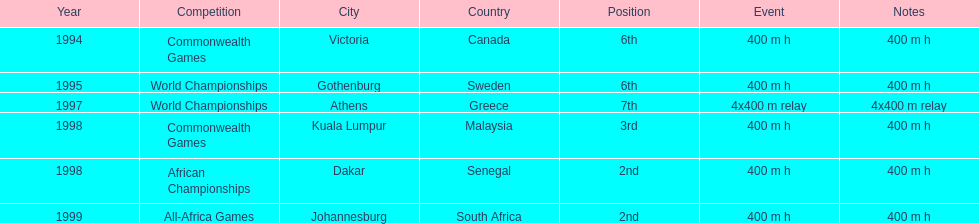What is the name of the last competition? All-Africa Games. 